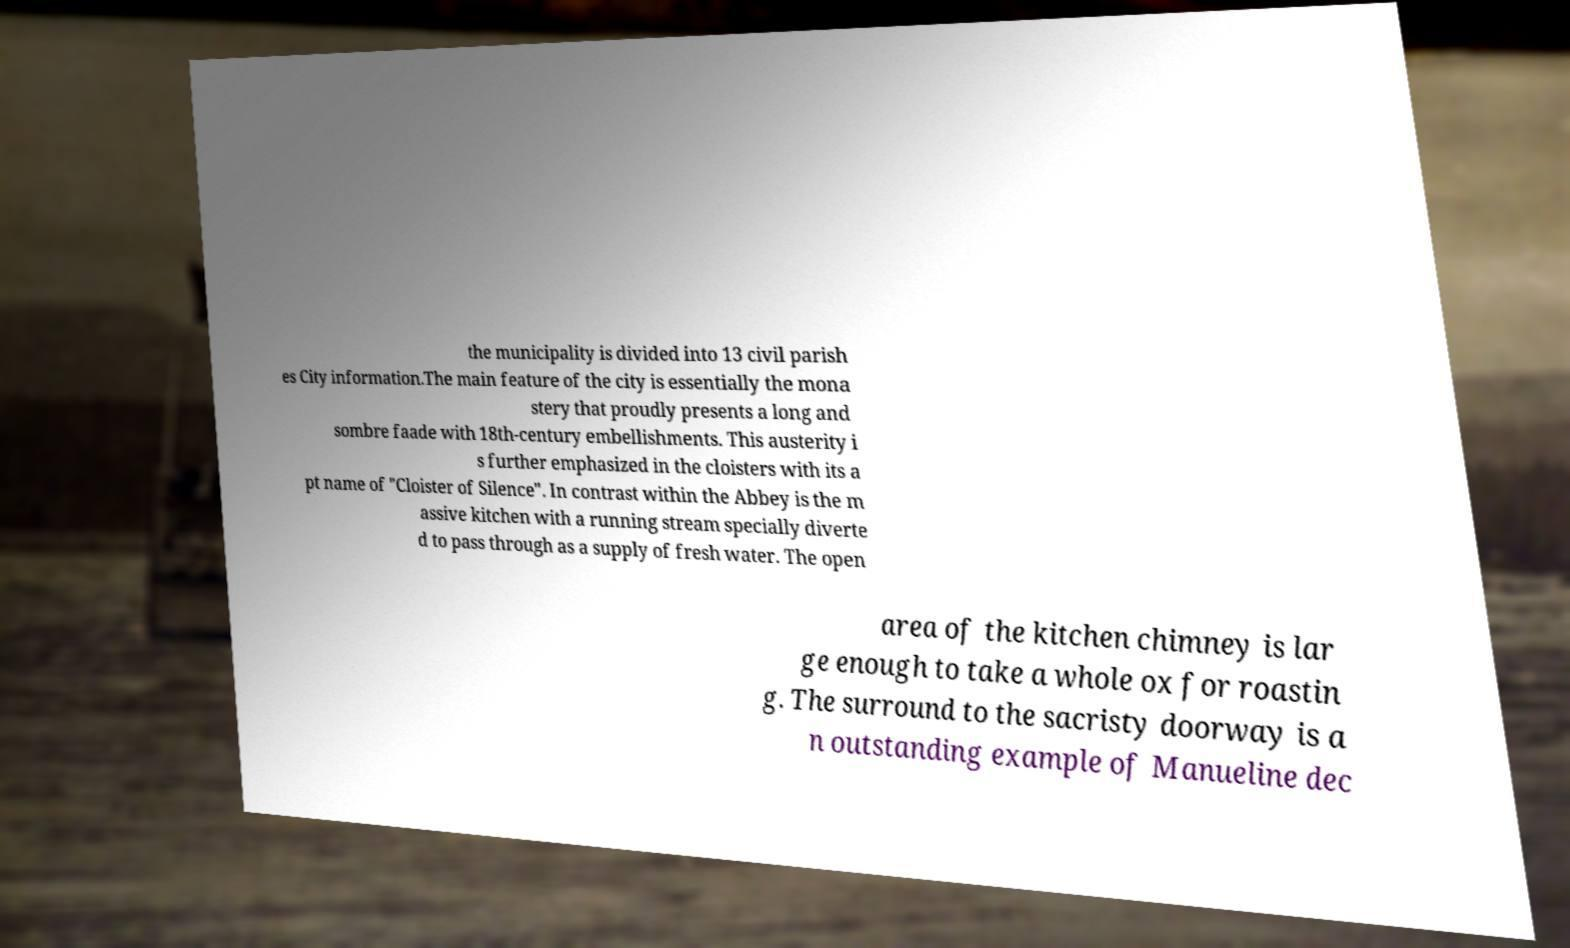Could you assist in decoding the text presented in this image and type it out clearly? the municipality is divided into 13 civil parish es City information.The main feature of the city is essentially the mona stery that proudly presents a long and sombre faade with 18th-century embellishments. This austerity i s further emphasized in the cloisters with its a pt name of "Cloister of Silence". In contrast within the Abbey is the m assive kitchen with a running stream specially diverte d to pass through as a supply of fresh water. The open area of the kitchen chimney is lar ge enough to take a whole ox for roastin g. The surround to the sacristy doorway is a n outstanding example of Manueline dec 